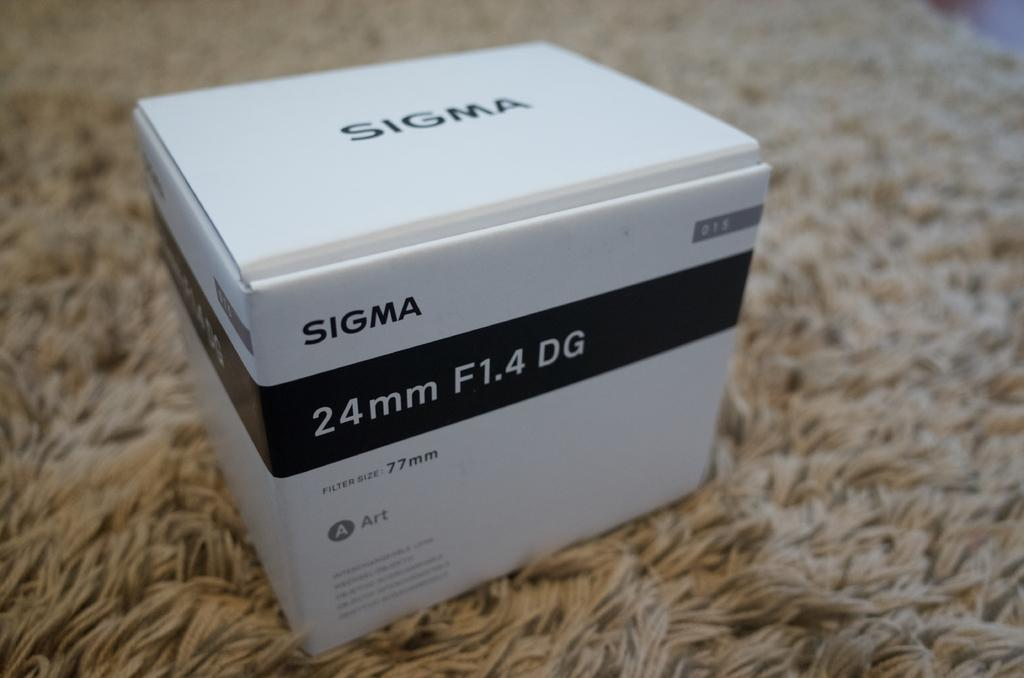<image>
Give a short and clear explanation of the subsequent image. A white Sigma package with the label 24mm F1.4 DG on the box 